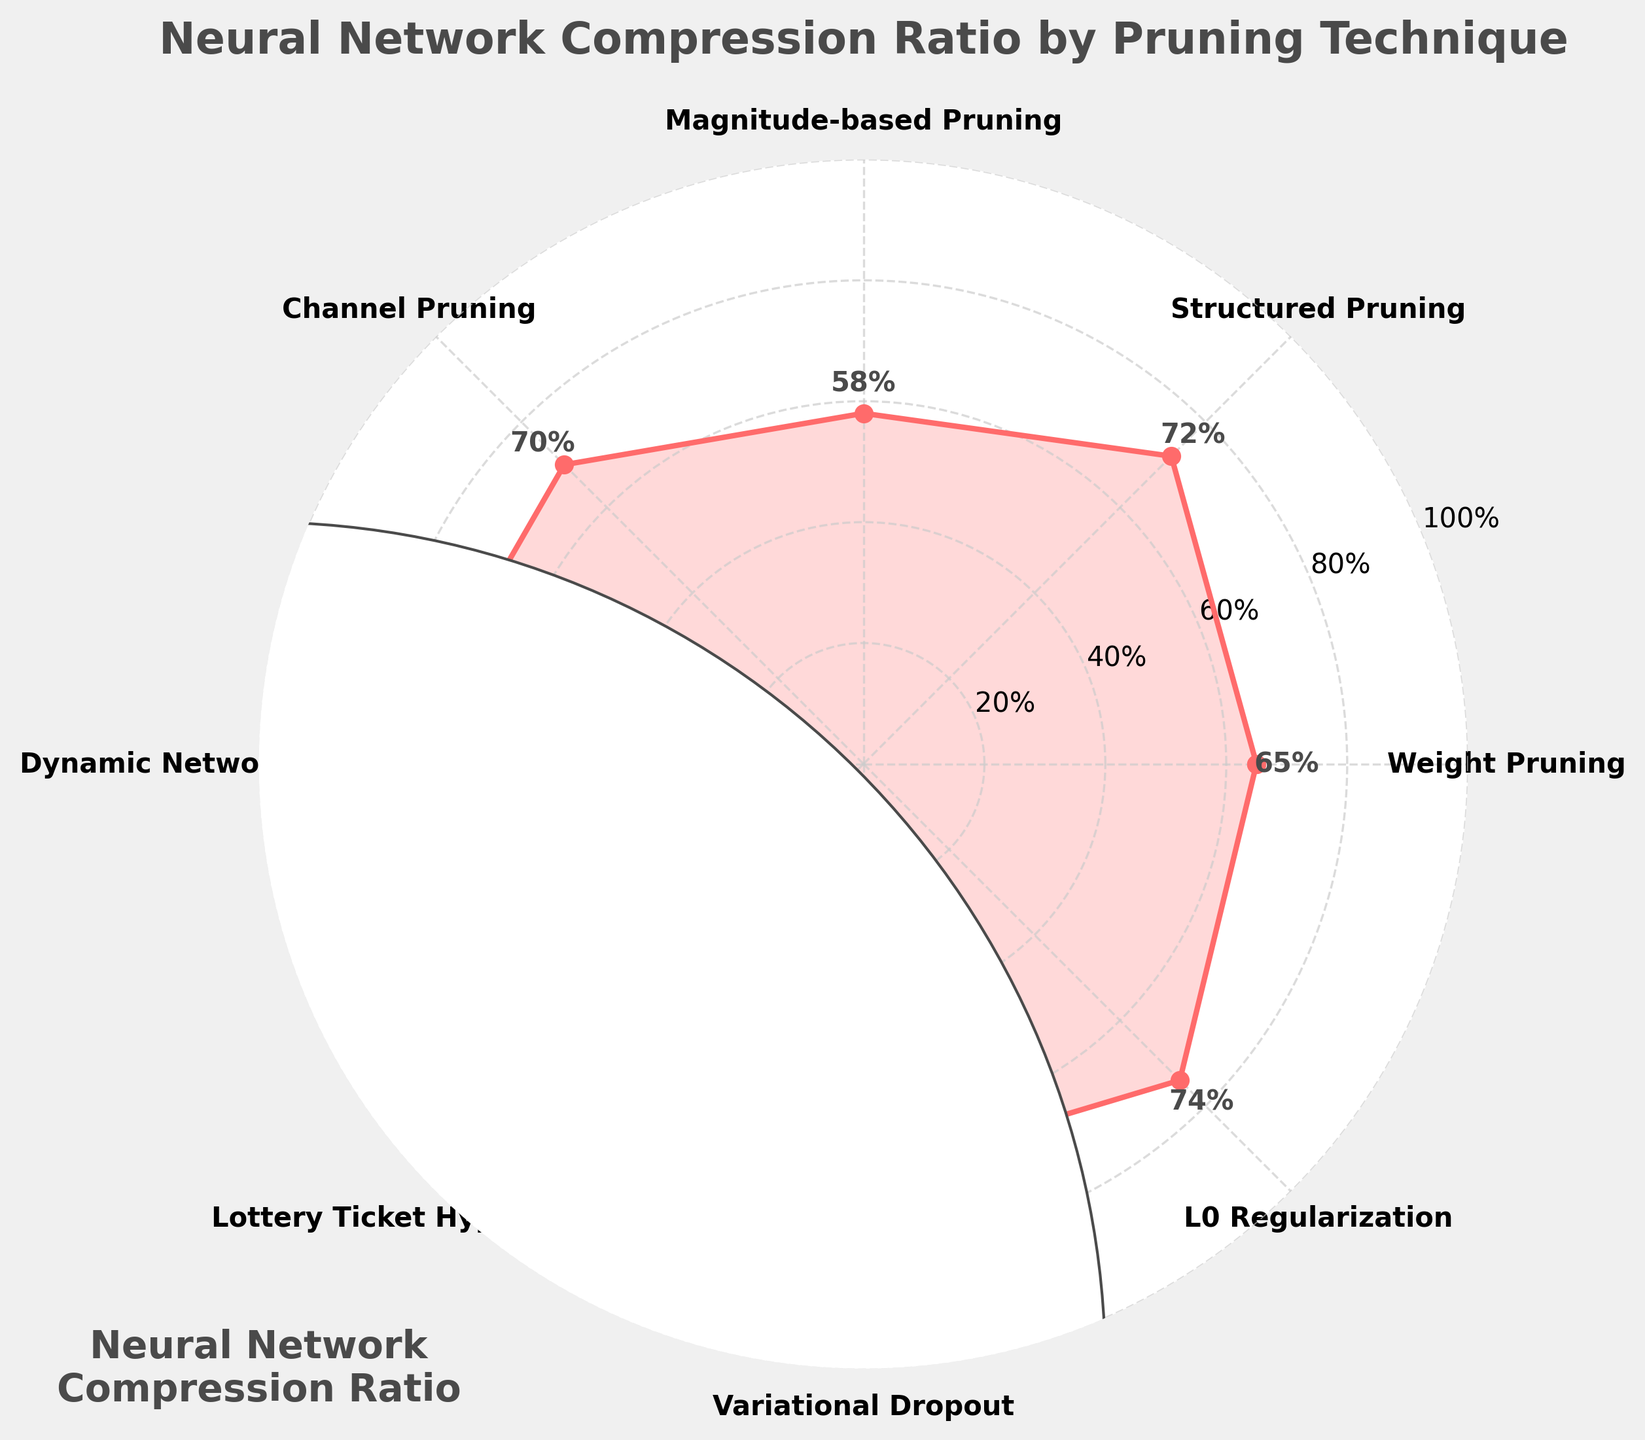What is the highest compression ratio achieved in the figure? Identify the highest value on the chart, which indicates the maximum compression ratio. The highest value is reached by Dynamic Network Surgery at 78%.
Answer: 78% What is the title of the figure? The title can be found at the top of the figure, indicating what the chart represents. It is "Neural Network Compression Ratio by Pruning Technique".
Answer: Neural Network Compression Ratio by Pruning Technique How many pruning techniques are displayed in the figure? Count the number of unique labels or segments around the chart. There are eight different pruning techniques shown.
Answer: 8 Which pruning technique has the lowest compression ratio? Locate the smallest value on the chart to determine which technique corresponds to it. Magnitude-based Pruning has the lowest compression ratio at 58%.
Answer: Magnitude-based Pruning What is the average compression ratio of all the pruning techniques? Add all the compression ratios and divide by the number of techniques to get the mean. Sum: 0.65 + 0.72 + 0.58 + 0.70 + 0.78 + 0.62 + 0.68 + 0.74 = 5.47. Average: 5.47 / 8 = 0.68375 (or 68.375%).
Answer: 68.375% How does the compression ratio of Channel Pruning compare to Lottery Ticket Hypothesis? Find the values for both techniques and compare them. Channel Pruning has a compression ratio of 70%, while Lottery Ticket Hypothesis has 62%. Channel Pruning is higher.
Answer: Channel Pruning is higher Which pruning techniques have a compression ratio above 70%? Identify all techniques with ratios greater than 70% by examining the chart. They are Structured Pruning (72%), Dynamic Network Surgery (78%), and L0 Regularization (74%).
Answer: Structured Pruning, Dynamic Network Surgery, L0 Regularization What is the difference in compression ratio between Weight Pruning and L0 Regularization? Subtract the compression ratio of Weight Pruning from that of L0 Regularization. Difference: 74% - 65% = 9%.
Answer: 9% Is the compression ratio of Variational Dropout closer to Structured Pruning or Channel Pruning? Determine the difference between Variational Dropout (68%) and Structured Pruning (72%) and between Variational Dropout and Channel Pruning (70%). Variational Dropout is closer to Channel Pruning (2% difference) than Structured Pruning (4%).
Answer: Channel Pruning 